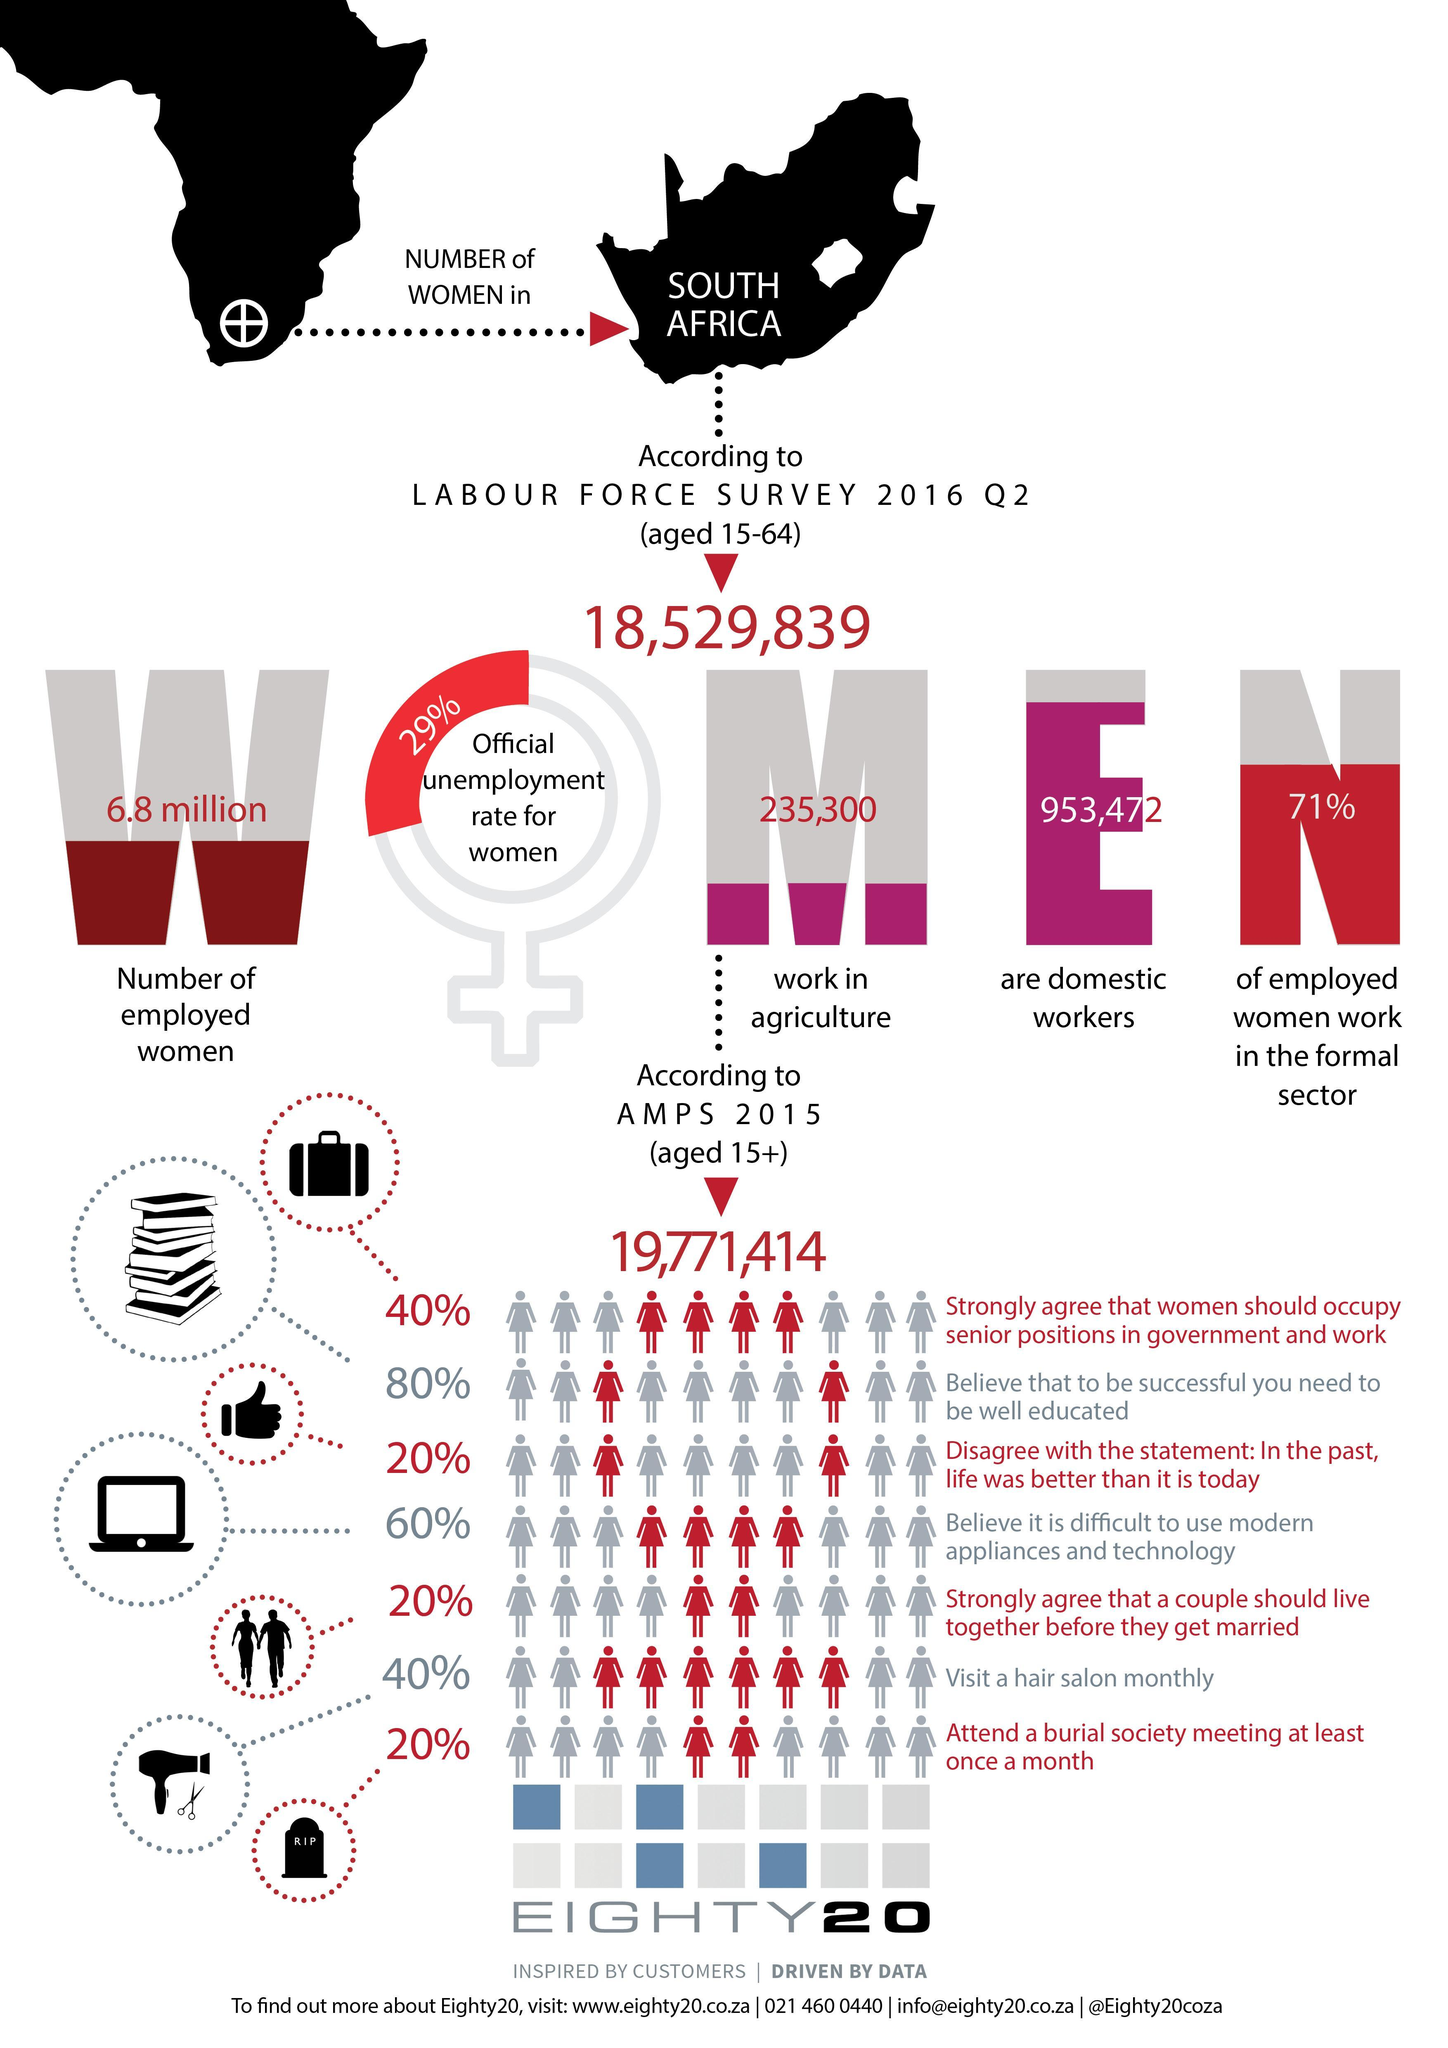What is the number of employed women aged 15-64 in South Africa according to the Labour force survey Q2 2016?
Answer the question with a short phrase. 6.8 million What is the number of women aged 15-64 working in the agricultural sector of South Africa according to the Labour force survey Q2 2016? 235,300 How many South African women aged 15-64  are domestic workers according to the Labour force survey Q2 2016? 953,472 What is the official unemployment rate for women in South Africa as per the Labour Force survey Q2 2016? 29% 